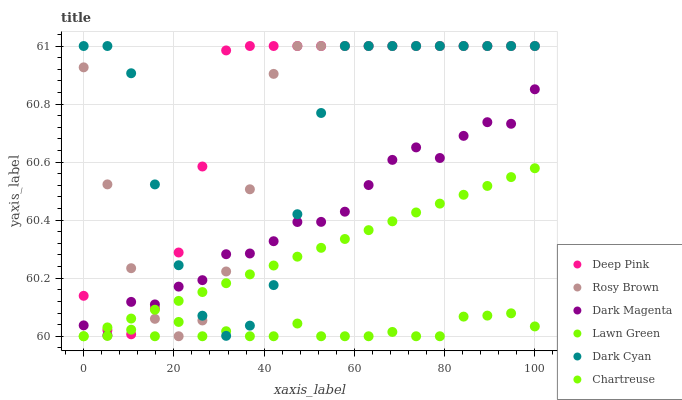Does Lawn Green have the minimum area under the curve?
Answer yes or no. Yes. Does Deep Pink have the maximum area under the curve?
Answer yes or no. Yes. Does Dark Magenta have the minimum area under the curve?
Answer yes or no. No. Does Dark Magenta have the maximum area under the curve?
Answer yes or no. No. Is Chartreuse the smoothest?
Answer yes or no. Yes. Is Dark Cyan the roughest?
Answer yes or no. Yes. Is Deep Pink the smoothest?
Answer yes or no. No. Is Deep Pink the roughest?
Answer yes or no. No. Does Lawn Green have the lowest value?
Answer yes or no. Yes. Does Dark Magenta have the lowest value?
Answer yes or no. No. Does Dark Cyan have the highest value?
Answer yes or no. Yes. Does Dark Magenta have the highest value?
Answer yes or no. No. Is Lawn Green less than Dark Magenta?
Answer yes or no. Yes. Is Dark Magenta greater than Lawn Green?
Answer yes or no. Yes. Does Lawn Green intersect Deep Pink?
Answer yes or no. Yes. Is Lawn Green less than Deep Pink?
Answer yes or no. No. Is Lawn Green greater than Deep Pink?
Answer yes or no. No. Does Lawn Green intersect Dark Magenta?
Answer yes or no. No. 